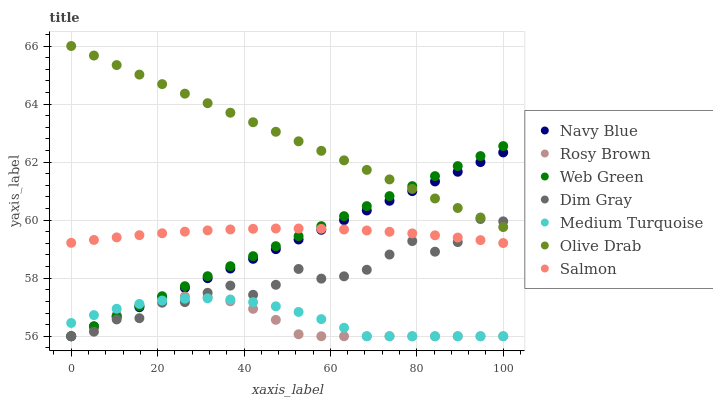Does Rosy Brown have the minimum area under the curve?
Answer yes or no. Yes. Does Olive Drab have the maximum area under the curve?
Answer yes or no. Yes. Does Navy Blue have the minimum area under the curve?
Answer yes or no. No. Does Navy Blue have the maximum area under the curve?
Answer yes or no. No. Is Navy Blue the smoothest?
Answer yes or no. Yes. Is Dim Gray the roughest?
Answer yes or no. Yes. Is Rosy Brown the smoothest?
Answer yes or no. No. Is Rosy Brown the roughest?
Answer yes or no. No. Does Dim Gray have the lowest value?
Answer yes or no. Yes. Does Salmon have the lowest value?
Answer yes or no. No. Does Olive Drab have the highest value?
Answer yes or no. Yes. Does Navy Blue have the highest value?
Answer yes or no. No. Is Medium Turquoise less than Olive Drab?
Answer yes or no. Yes. Is Olive Drab greater than Salmon?
Answer yes or no. Yes. Does Rosy Brown intersect Web Green?
Answer yes or no. Yes. Is Rosy Brown less than Web Green?
Answer yes or no. No. Is Rosy Brown greater than Web Green?
Answer yes or no. No. Does Medium Turquoise intersect Olive Drab?
Answer yes or no. No. 